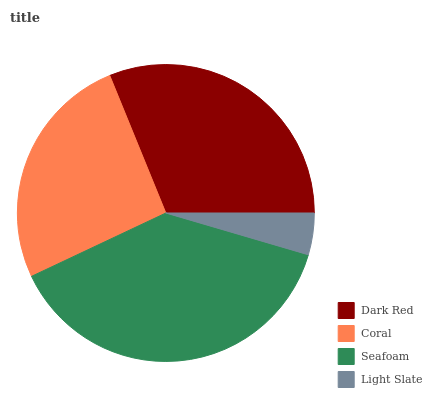Is Light Slate the minimum?
Answer yes or no. Yes. Is Seafoam the maximum?
Answer yes or no. Yes. Is Coral the minimum?
Answer yes or no. No. Is Coral the maximum?
Answer yes or no. No. Is Dark Red greater than Coral?
Answer yes or no. Yes. Is Coral less than Dark Red?
Answer yes or no. Yes. Is Coral greater than Dark Red?
Answer yes or no. No. Is Dark Red less than Coral?
Answer yes or no. No. Is Dark Red the high median?
Answer yes or no. Yes. Is Coral the low median?
Answer yes or no. Yes. Is Coral the high median?
Answer yes or no. No. Is Seafoam the low median?
Answer yes or no. No. 